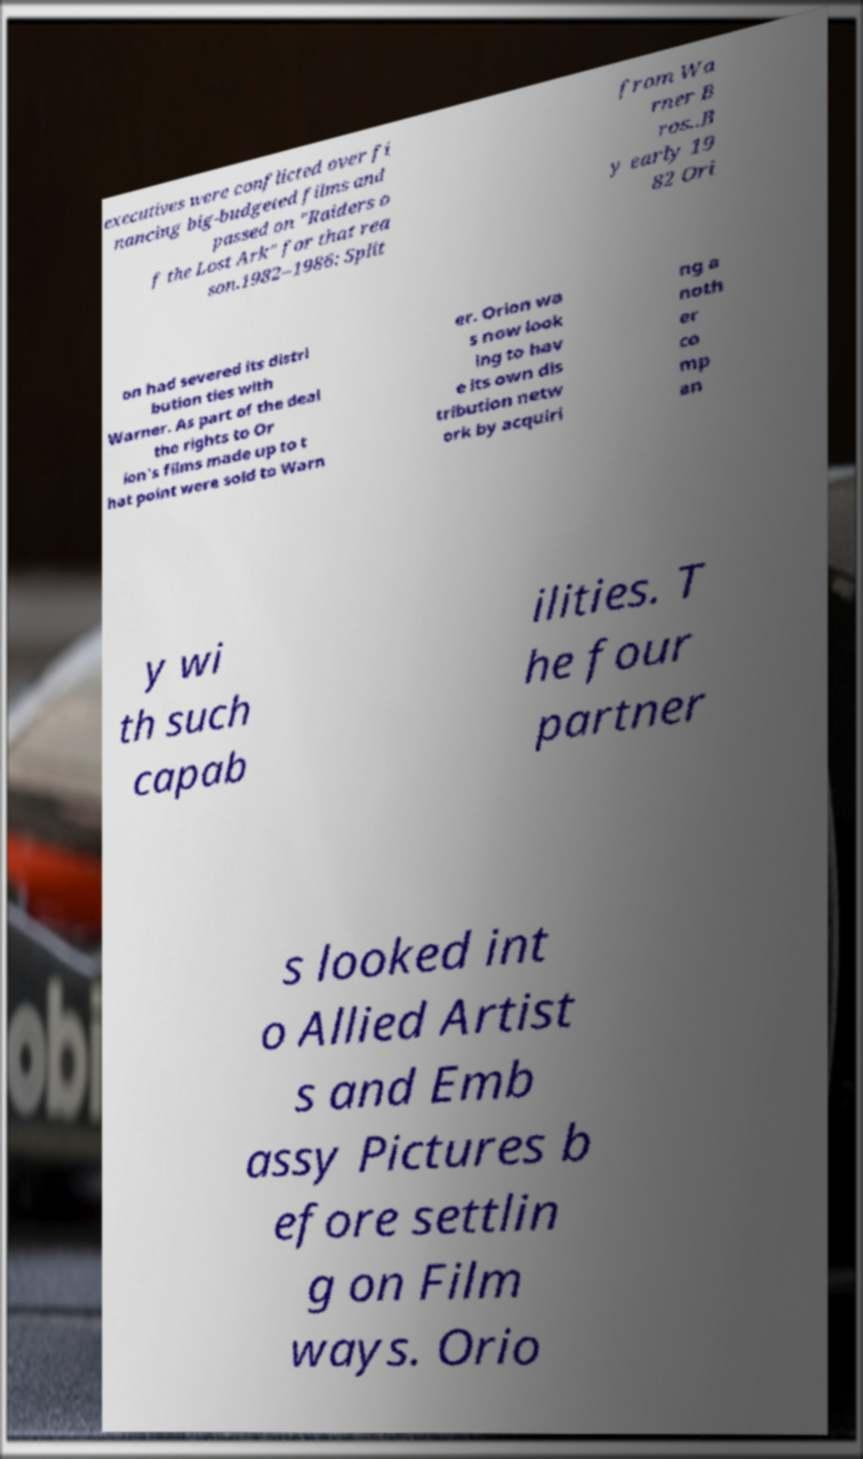I need the written content from this picture converted into text. Can you do that? executives were conflicted over fi nancing big-budgeted films and passed on "Raiders o f the Lost Ark" for that rea son.1982–1986: Split from Wa rner B ros..B y early 19 82 Ori on had severed its distri bution ties with Warner. As part of the deal the rights to Or ion's films made up to t hat point were sold to Warn er. Orion wa s now look ing to hav e its own dis tribution netw ork by acquiri ng a noth er co mp an y wi th such capab ilities. T he four partner s looked int o Allied Artist s and Emb assy Pictures b efore settlin g on Film ways. Orio 